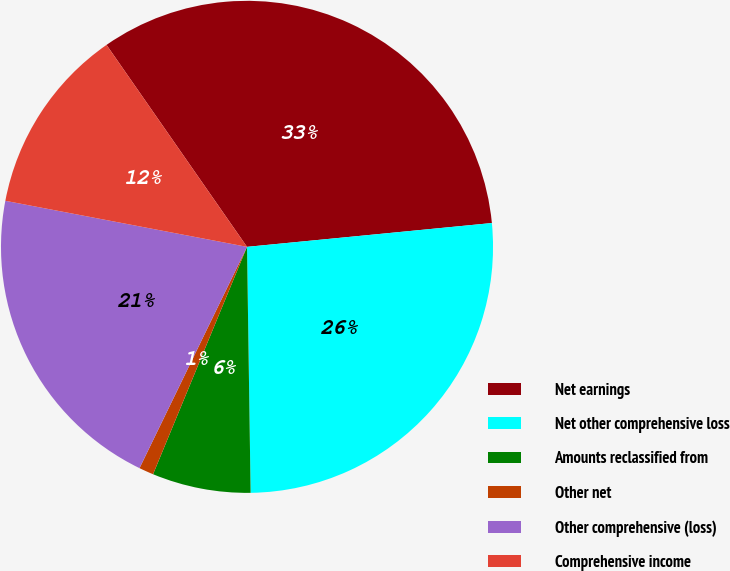<chart> <loc_0><loc_0><loc_500><loc_500><pie_chart><fcel>Net earnings<fcel>Net other comprehensive loss<fcel>Amounts reclassified from<fcel>Other net<fcel>Other comprehensive (loss)<fcel>Comprehensive income<nl><fcel>33.13%<fcel>26.31%<fcel>6.47%<fcel>0.96%<fcel>20.8%<fcel>12.33%<nl></chart> 